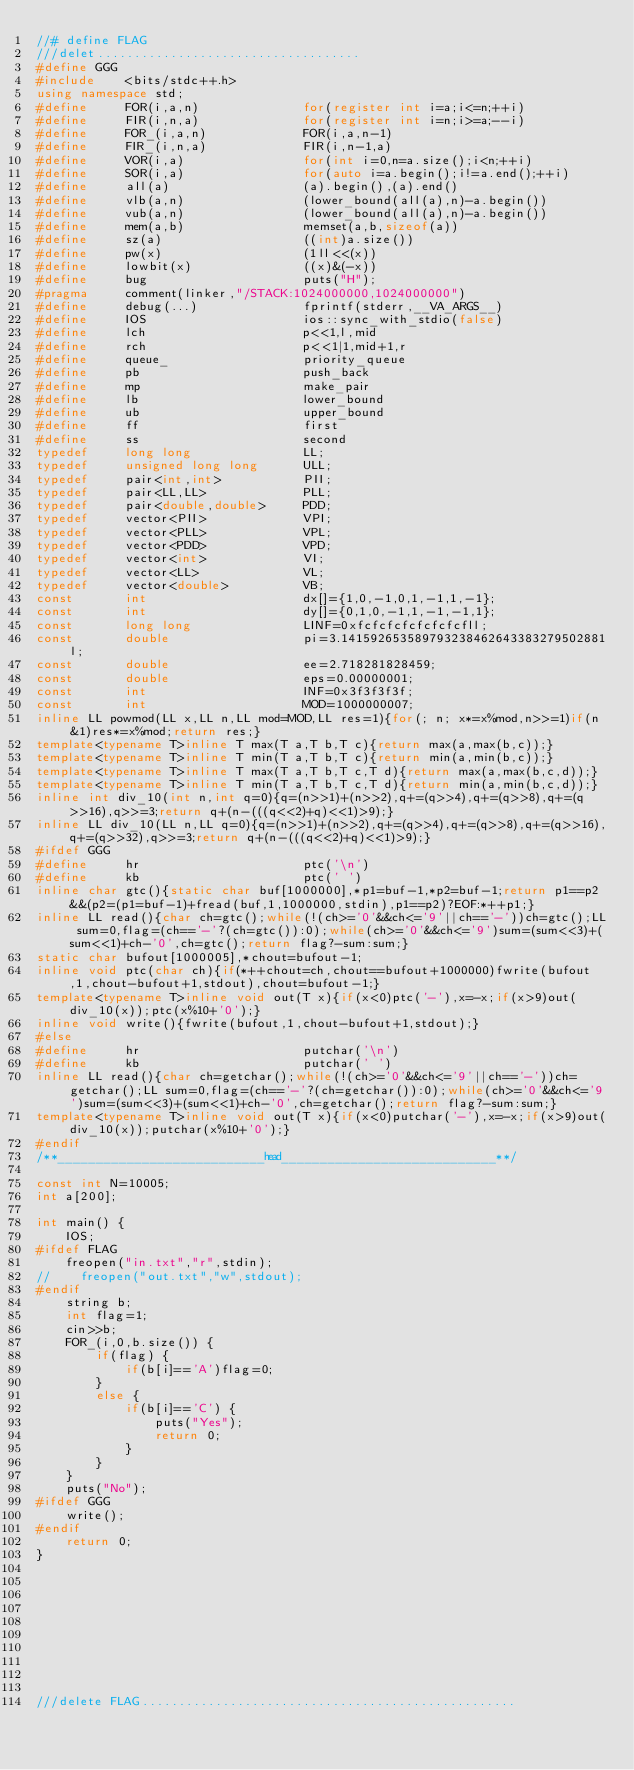Convert code to text. <code><loc_0><loc_0><loc_500><loc_500><_C++_>//# define FLAG
///delet....................................
#define GGG
#include    <bits/stdc++.h>
using namespace std;
#define     FOR(i,a,n)              for(register int i=a;i<=n;++i)
#define     FIR(i,n,a)              for(register int i=n;i>=a;--i)
#define     FOR_(i,a,n)             FOR(i,a,n-1)
#define     FIR_(i,n,a)             FIR(i,n-1,a)
#define     VOR(i,a)                for(int i=0,n=a.size();i<n;++i)
#define     SOR(i,a)                for(auto i=a.begin();i!=a.end();++i)
#define     all(a)                  (a).begin(),(a).end()
#define     vlb(a,n)                (lower_bound(all(a),n)-a.begin())
#define     vub(a,n)                (lower_bound(all(a),n)-a.begin())
#define     mem(a,b)                memset(a,b,sizeof(a))
#define     sz(a)                   ((int)a.size())
#define     pw(x)                   (1ll<<(x))
#define     lowbit(x)               ((x)&(-x))
#define     bug                     puts("H");
#pragma     comment(linker,"/STACK:1024000000,1024000000")
#define     debug(...)              fprintf(stderr,__VA_ARGS__)
#define     IOS                     ios::sync_with_stdio(false)
#define     lch                     p<<1,l,mid
#define     rch                     p<<1|1,mid+1,r
#define     queue_                  priority_queue
#define     pb                      push_back
#define     mp                      make_pair
#define     lb                      lower_bound
#define     ub                      upper_bound
#define     ff                      first
#define     ss                      second
typedef     long long               LL;
typedef     unsigned long long      ULL;
typedef     pair<int,int>           PII;
typedef     pair<LL,LL>             PLL;
typedef     pair<double,double>     PDD;
typedef     vector<PII>             VPI;
typedef     vector<PLL>             VPL;
typedef     vector<PDD>             VPD;
typedef     vector<int>             VI;
typedef     vector<LL>              VL;
typedef     vector<double>          VB;
const       int                     dx[]={1,0,-1,0,1,-1,1,-1};
const       int                     dy[]={0,1,0,-1,1,-1,-1,1};
const       long long               LINF=0xfcfcfcfcfcfcfcfll;
const       double                  pi=3.141592653589793238462643383279502881l;
const       double                  ee=2.718281828459;
const       double                  eps=0.00000001;
const       int                     INF=0x3f3f3f3f;
const       int                     MOD=1000000007;
inline LL powmod(LL x,LL n,LL mod=MOD,LL res=1){for(; n; x*=x%mod,n>>=1)if(n&1)res*=x%mod;return res;}
template<typename T>inline T max(T a,T b,T c){return max(a,max(b,c));}
template<typename T>inline T min(T a,T b,T c){return min(a,min(b,c));}
template<typename T>inline T max(T a,T b,T c,T d){return max(a,max(b,c,d));}
template<typename T>inline T min(T a,T b,T c,T d){return min(a,min(b,c,d));}
inline int div_10(int n,int q=0){q=(n>>1)+(n>>2),q+=(q>>4),q+=(q>>8),q+=(q>>16),q>>=3;return q+(n-(((q<<2)+q)<<1)>9);}
inline LL div_10(LL n,LL q=0){q=(n>>1)+(n>>2),q+=(q>>4),q+=(q>>8),q+=(q>>16),q+=(q>>32),q>>=3;return q+(n-(((q<<2)+q)<<1)>9);}
#ifdef GGG
#define     hr                      ptc('\n')
#define     kb                      ptc(' ')
inline char gtc(){static char buf[1000000],*p1=buf-1,*p2=buf-1;return p1==p2&&(p2=(p1=buf-1)+fread(buf,1,1000000,stdin),p1==p2)?EOF:*++p1;}
inline LL read(){char ch=gtc();while(!(ch>='0'&&ch<='9'||ch=='-'))ch=gtc();LL sum=0,flag=(ch=='-'?(ch=gtc()):0);while(ch>='0'&&ch<='9')sum=(sum<<3)+(sum<<1)+ch-'0',ch=gtc();return flag?-sum:sum;}
static char bufout[1000005],*chout=bufout-1;
inline void ptc(char ch){if(*++chout=ch,chout==bufout+1000000)fwrite(bufout,1,chout-bufout+1,stdout),chout=bufout-1;}
template<typename T>inline void out(T x){if(x<0)ptc('-'),x=-x;if(x>9)out(div_10(x));ptc(x%10+'0');}
inline void write(){fwrite(bufout,1,chout-bufout+1,stdout);}
#else
#define     hr                      putchar('\n')
#define     kb                      putchar(' ')
inline LL read(){char ch=getchar();while(!(ch>='0'&&ch<='9'||ch=='-'))ch=getchar();LL sum=0,flag=(ch=='-'?(ch=getchar()):0);while(ch>='0'&&ch<='9')sum=(sum<<3)+(sum<<1)+ch-'0',ch=getchar();return flag?-sum:sum;}
template<typename T>inline void out(T x){if(x<0)putchar('-'),x=-x;if(x>9)out(div_10(x));putchar(x%10+'0');}
#endif
/**___________________________head____________________________**/

const int N=10005;
int a[200];

int main() {
    IOS;
#ifdef FLAG
    freopen("in.txt","r",stdin);
//    freopen("out.txt","w",stdout);
#endif
    string b;
    int flag=1;
    cin>>b;
    FOR_(i,0,b.size()) {
        if(flag) {
            if(b[i]=='A')flag=0;
        }
        else {
            if(b[i]=='C') {
                puts("Yes");
                return 0;
            }
        }
    }
    puts("No");
#ifdef GGG
    write();
#endif
    return 0;
}










///delete FLAG...................................................



</code> 